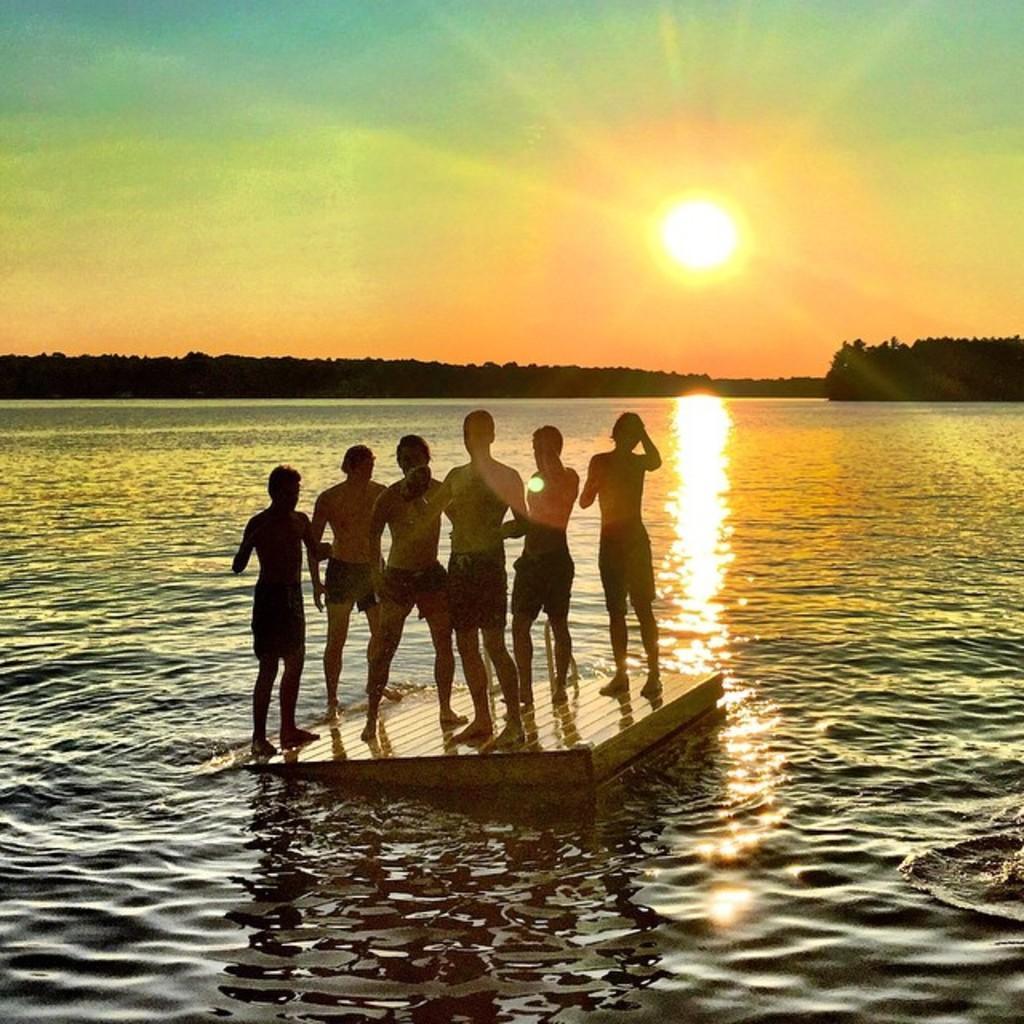Can you describe this image briefly? Here in this picture we can see a group of men standing on the wooden raft, which is present in the river over there, as we can see water present all over there and in the far we can see mountains covered with trees over there and we can see sun in the sky over there. 